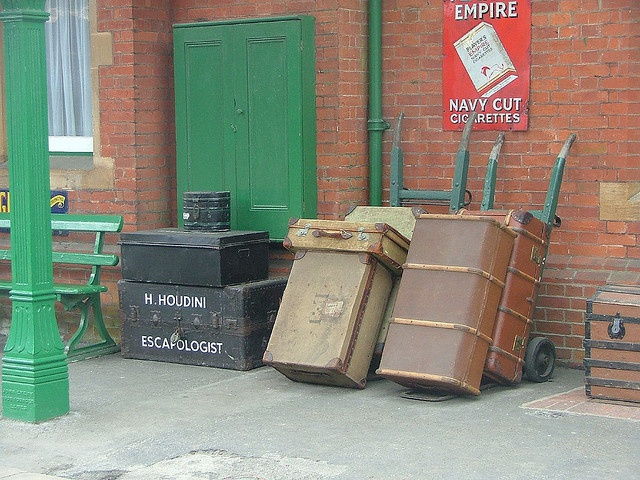Describe the objects in this image and their specific colors. I can see suitcase in teal, darkgray, and gray tones, suitcase in teal, tan, and gray tones, suitcase in teal, gray, black, purple, and white tones, bench in teal, gray, and turquoise tones, and suitcase in teal, purple, black, and darkgray tones in this image. 